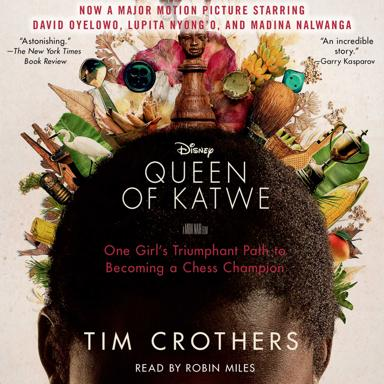Who are the main actors in the movie 'Queen of Katwe'? The movie 'Queen of Katwe' features stellar performances by David Oyelowo, Lupita Nyong'o, and Madina Nalwanga, whose roles bring depth and authenticity to this inspiring story. 